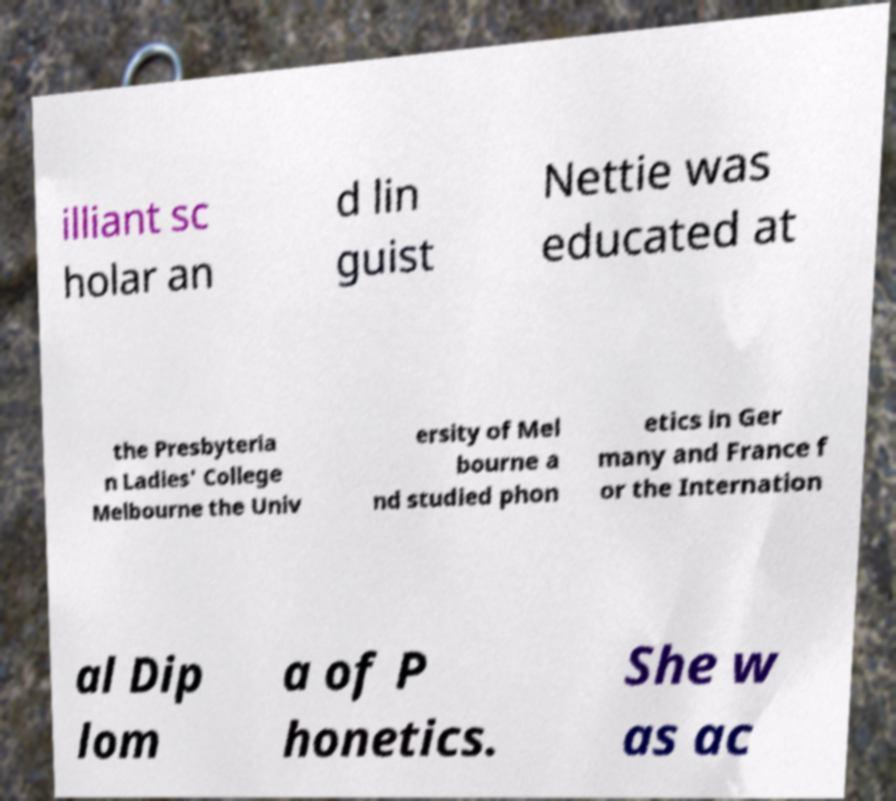For documentation purposes, I need the text within this image transcribed. Could you provide that? illiant sc holar an d lin guist Nettie was educated at the Presbyteria n Ladies' College Melbourne the Univ ersity of Mel bourne a nd studied phon etics in Ger many and France f or the Internation al Dip lom a of P honetics. She w as ac 